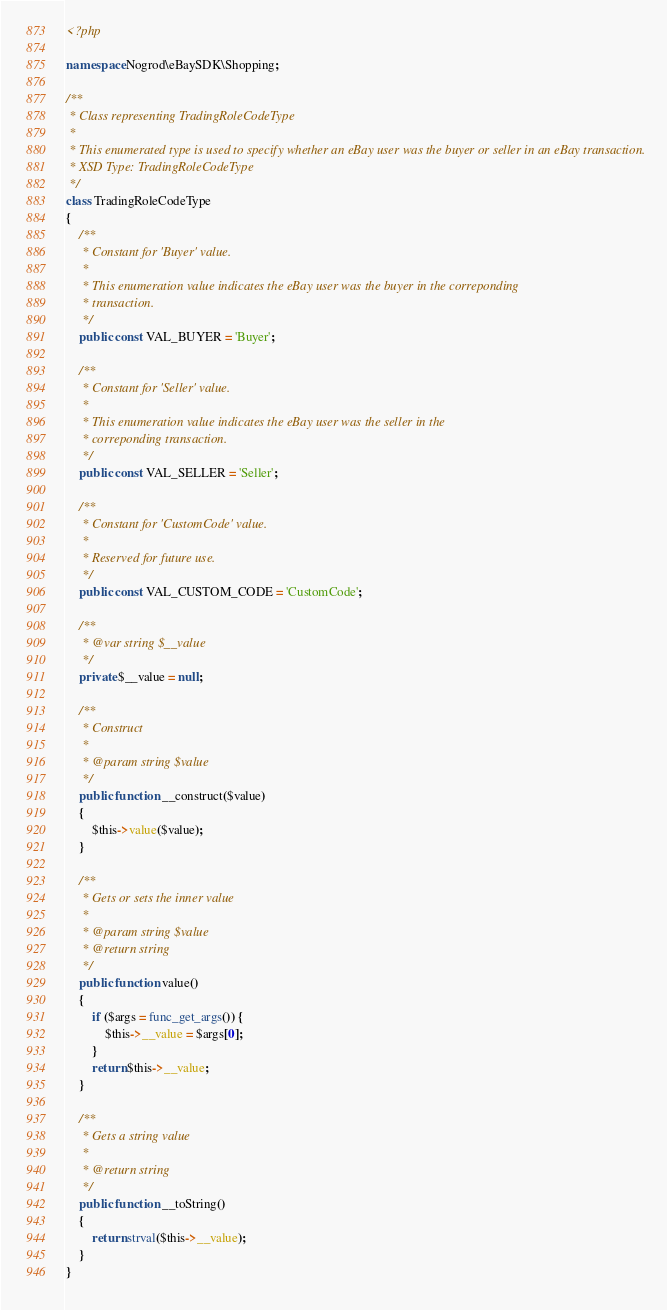<code> <loc_0><loc_0><loc_500><loc_500><_PHP_><?php

namespace Nogrod\eBaySDK\Shopping;

/**
 * Class representing TradingRoleCodeType
 *
 * This enumerated type is used to specify whether an eBay user was the buyer or seller in an eBay transaction.
 * XSD Type: TradingRoleCodeType
 */
class TradingRoleCodeType
{
    /**
     * Constant for 'Buyer' value.
     *
     * This enumeration value indicates the eBay user was the buyer in the correponding
     * transaction.
     */
    public const VAL_BUYER = 'Buyer';

    /**
     * Constant for 'Seller' value.
     *
     * This enumeration value indicates the eBay user was the seller in the
     * correponding transaction.
     */
    public const VAL_SELLER = 'Seller';

    /**
     * Constant for 'CustomCode' value.
     *
     * Reserved for future use.
     */
    public const VAL_CUSTOM_CODE = 'CustomCode';

    /**
     * @var string $__value
     */
    private $__value = null;

    /**
     * Construct
     *
     * @param string $value
     */
    public function __construct($value)
    {
        $this->value($value);
    }

    /**
     * Gets or sets the inner value
     *
     * @param string $value
     * @return string
     */
    public function value()
    {
        if ($args = func_get_args()) {
            $this->__value = $args[0];
        }
        return $this->__value;
    }

    /**
     * Gets a string value
     *
     * @return string
     */
    public function __toString()
    {
        return strval($this->__value);
    }
}
</code> 